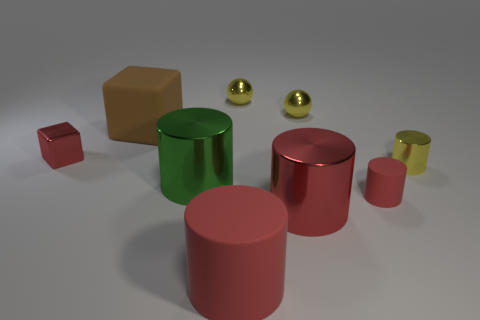Is there a thing that has the same color as the tiny metal cylinder?
Your response must be concise. Yes. What is the material of the big object that is the same color as the large matte cylinder?
Keep it short and to the point. Metal. There is a metallic object that is in front of the big green cylinder; how big is it?
Ensure brevity in your answer.  Large. There is a red matte object on the right side of the large matte thing that is in front of the large matte block; how many yellow metal cylinders are behind it?
Give a very brief answer. 1. Is the metallic block the same color as the large cube?
Ensure brevity in your answer.  No. What number of metal things are both behind the small shiny cylinder and on the left side of the big red metal cylinder?
Your answer should be very brief. 2. What shape is the red object that is to the left of the big brown object?
Provide a succinct answer. Cube. Is the number of tiny red matte things on the left side of the tiny rubber cylinder less than the number of big shiny cylinders to the left of the green object?
Give a very brief answer. No. Is the small object to the left of the big red rubber object made of the same material as the large object behind the big green cylinder?
Ensure brevity in your answer.  No. What is the shape of the green object?
Make the answer very short. Cylinder. 